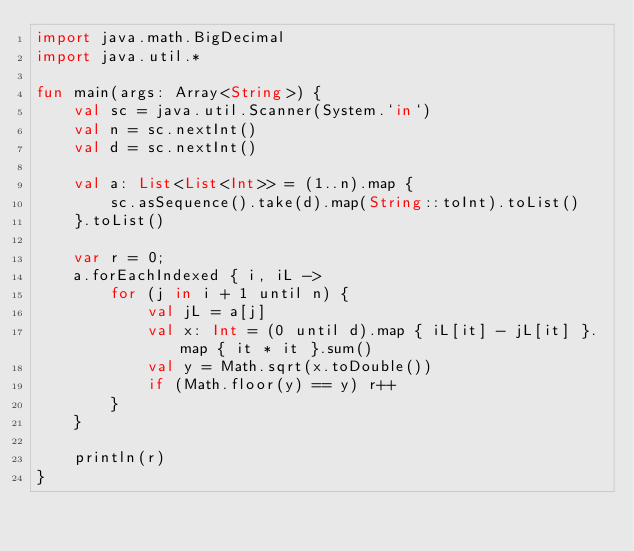<code> <loc_0><loc_0><loc_500><loc_500><_Kotlin_>import java.math.BigDecimal
import java.util.*

fun main(args: Array<String>) {
    val sc = java.util.Scanner(System.`in`)
    val n = sc.nextInt()
    val d = sc.nextInt()

    val a: List<List<Int>> = (1..n).map {
        sc.asSequence().take(d).map(String::toInt).toList()
    }.toList()

    var r = 0;
    a.forEachIndexed { i, iL ->
        for (j in i + 1 until n) {
            val jL = a[j]
            val x: Int = (0 until d).map { iL[it] - jL[it] }.map { it * it }.sum()
            val y = Math.sqrt(x.toDouble())
            if (Math.floor(y) == y) r++
        }
    }

    println(r)
}
</code> 